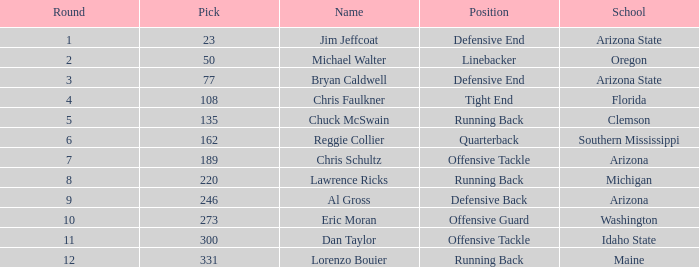What is the largest pick in round 8? 220.0. 